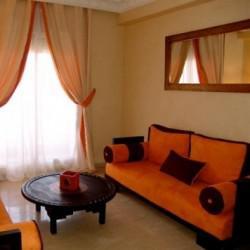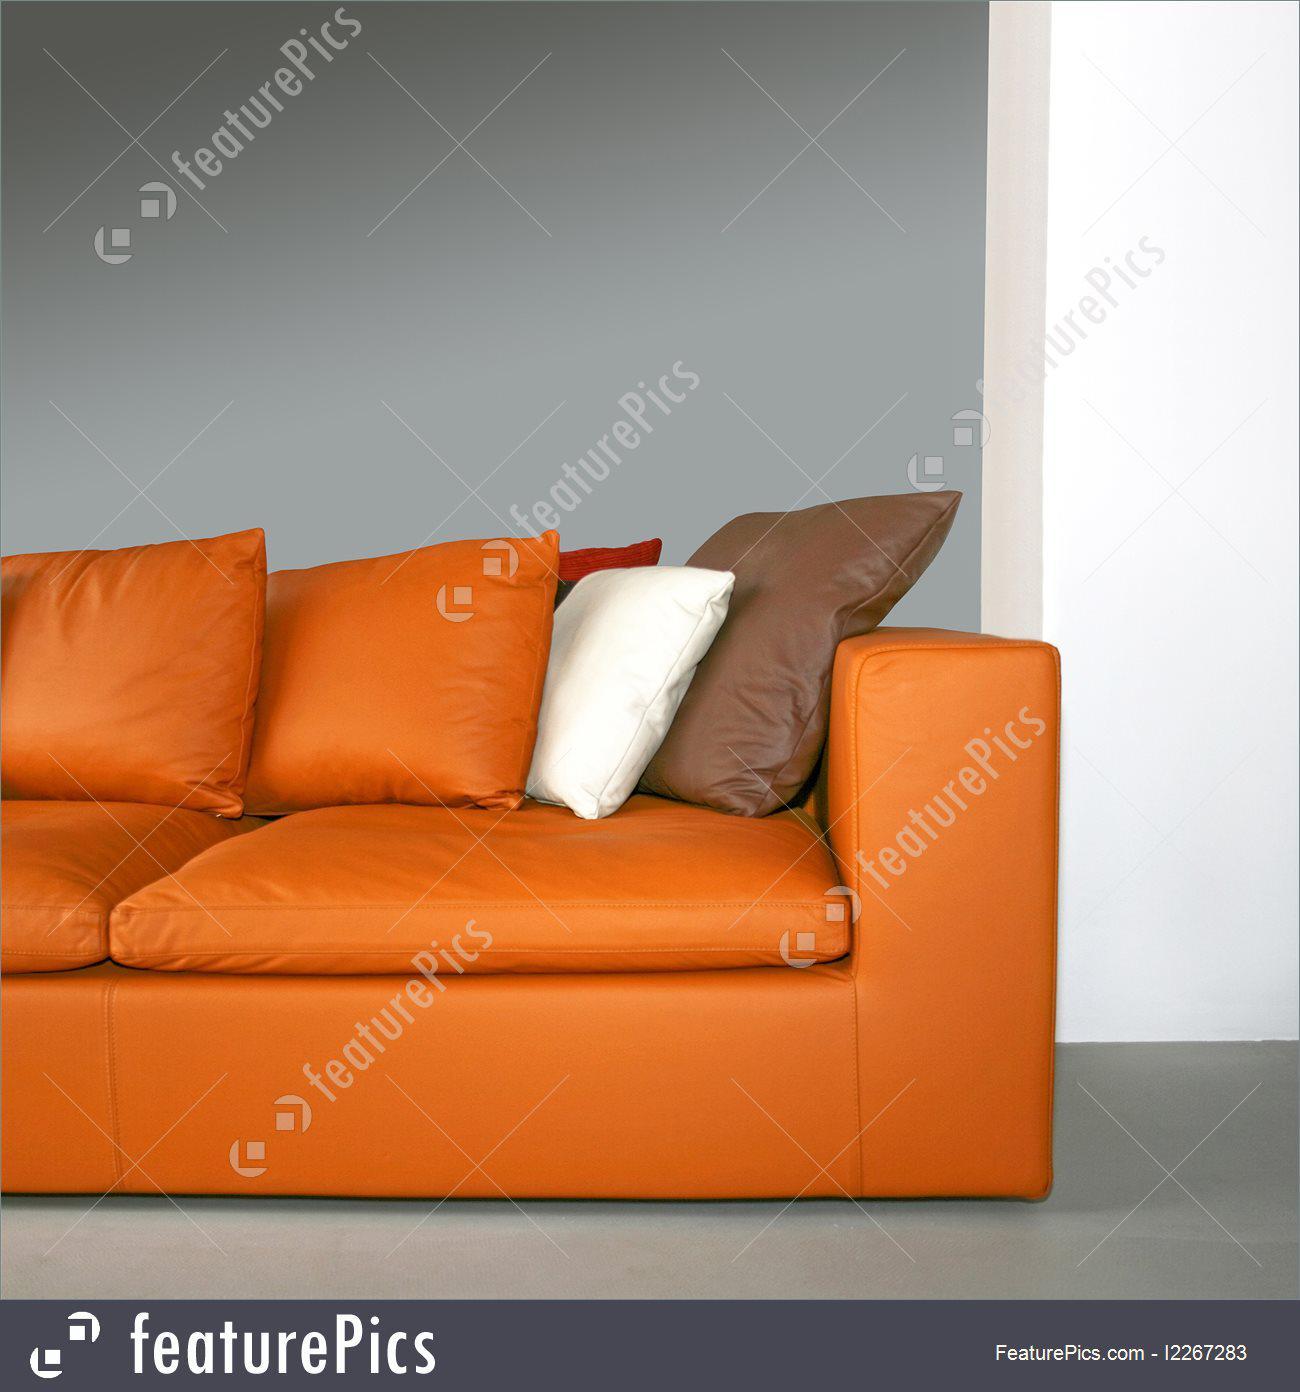The first image is the image on the left, the second image is the image on the right. Assess this claim about the two images: "The pillows on one of the images are sitting on a brown couch.". Correct or not? Answer yes or no. No. The first image is the image on the left, the second image is the image on the right. For the images shown, is this caption "One room includes an orange sectional couch that forms a corner, in front of hanging orange drapes." true? Answer yes or no. No. 